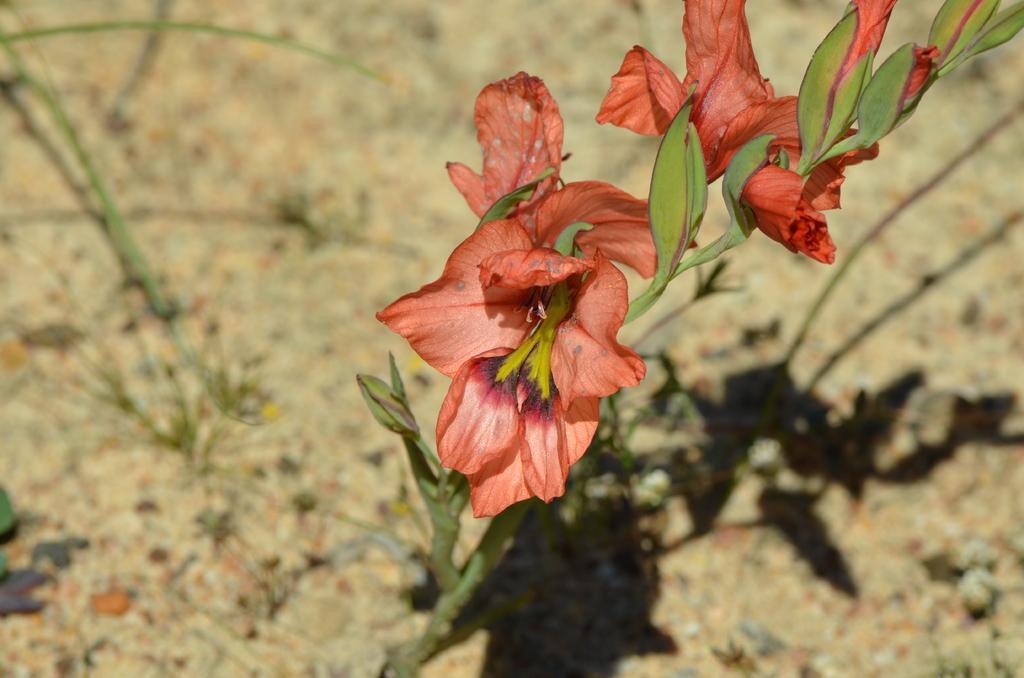Can you describe this image briefly? In this image I can see orange colour flowers and green colour leaves. I can also see shadows in background and I can see this image is little bit blurry from background. 